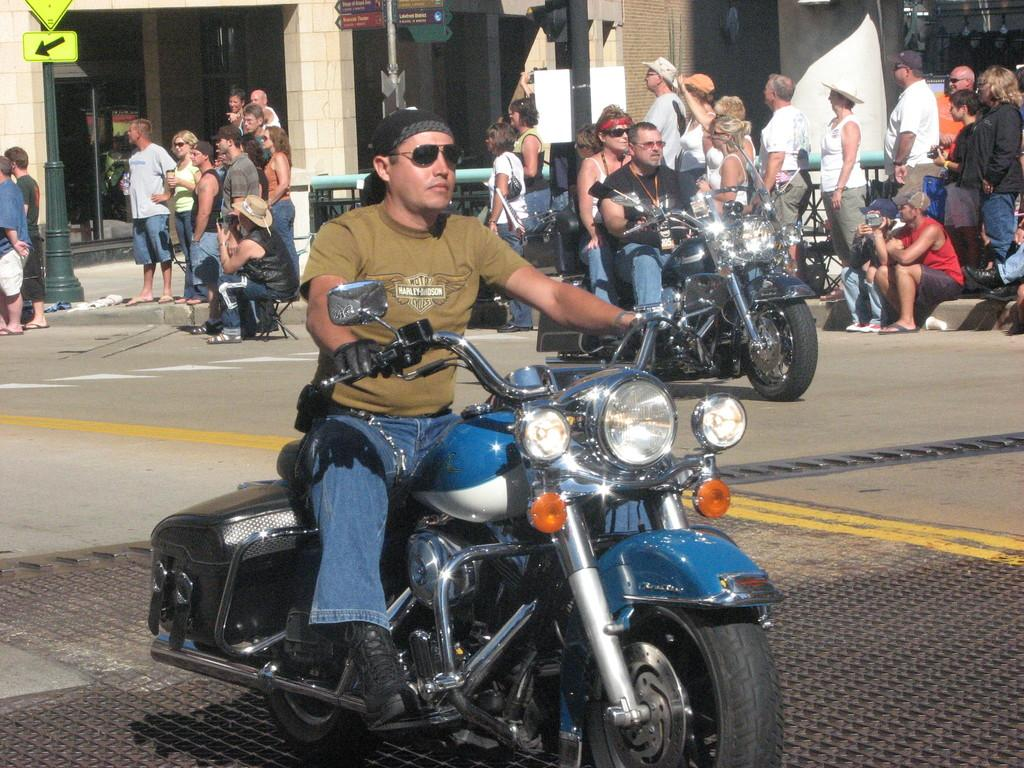What is the man in the image doing? The man is riding a bike on the road. Are there any other people in the image? Yes, there are people standing behind the man and two people on bikes riding behind him. What can be seen in the background of the image? There is a building in the background. What is the purpose of the sign pole visible in the image? The purpose of the sign pole is not clear from the image, but it could be for displaying signs or advertisements. What type of clouds can be seen in the image? There are no clouds visible in the image; it appears to be a clear day. How many beds are present in the image? There are no beds present in the image; it features a man riding a bike and other people on bikes or standing nearby. 